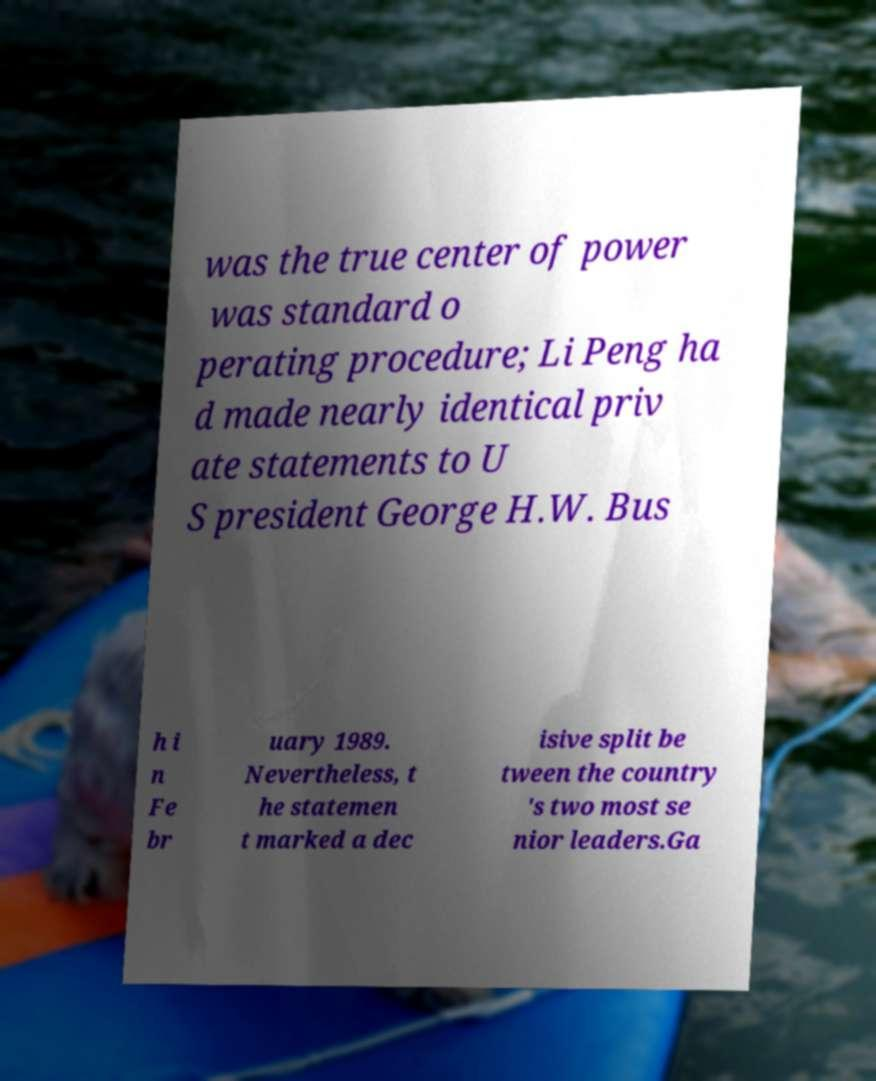What messages or text are displayed in this image? I need them in a readable, typed format. was the true center of power was standard o perating procedure; Li Peng ha d made nearly identical priv ate statements to U S president George H.W. Bus h i n Fe br uary 1989. Nevertheless, t he statemen t marked a dec isive split be tween the country 's two most se nior leaders.Ga 